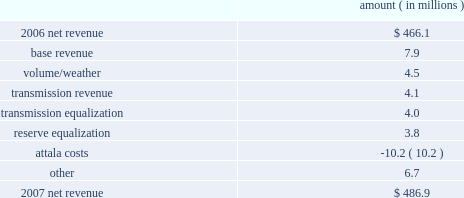Entergy mississippi , inc .
Management's financial discussion and analysis the net wholesale revenue variance is primarily due to lower profit on joint account sales and reduced capacity revenue from the municipal energy agency of mississippi .
Gross operating revenues , fuel and purchased power expenses , and other regulatory charges gross operating revenues increased primarily due to an increase of $ 152.5 million in fuel cost recovery revenues due to higher fuel rates , partially offset by a decrease of $ 43 million in gross wholesale revenues due to a decrease in net generation and purchases in excess of decreased net area demand resulting in less energy available for resale sales coupled with a decrease in system agreement remedy receipts .
Fuel and purchased power expenses increased primarily due to increases in the average market prices of natural gas and purchased power , partially offset by decreased demand and decreased recovery from customers of deferred fuel costs .
Other regulatory charges increased primarily due to increased recovery through the grand gulf rider of grand gulf capacity costs due to higher rates and increased recovery of costs associated with the power management recovery rider .
There is no material effect on net income due to quarterly adjustments to the power management recovery rider .
2007 compared to 2006 net revenue consists of operating revenues net of : 1 ) fuel , fuel-related expenses , and gas purchased for resale , 2 ) purchased power expenses , and 3 ) other regulatory charges ( credits ) .
Following is an analysis of the change in net revenue comparing 2007 to 2006 .
Amount ( in millions ) .
The base revenue variance is primarily due to a formula rate plan increase effective july 2007 .
The formula rate plan filing is discussed further in "state and local rate regulation" below .
The volume/weather variance is primarily due to increased electricity usage primarily in the residential and commercial sectors , including the effect of more favorable weather on billed electric sales in 2007 compared to 2006 .
Billed electricity usage increased 214 gwh .
The increase in usage was partially offset by decreased usage in the industrial sector .
The transmission revenue variance is due to higher rates and the addition of new transmission customers in late 2006 .
The transmission equalization variance is primarily due to a revision made in 2006 of transmission equalization receipts among entergy companies .
The reserve equalization variance is primarily due to a revision in 2006 of reserve equalization payments among entergy companies due to a ferc ruling regarding the inclusion of interruptible loads in reserve .
What is the percent change between net revenue in 2006 and 2007? 
Computations: ((486.9 - 466.1) / 466.1)
Answer: 0.04463. 